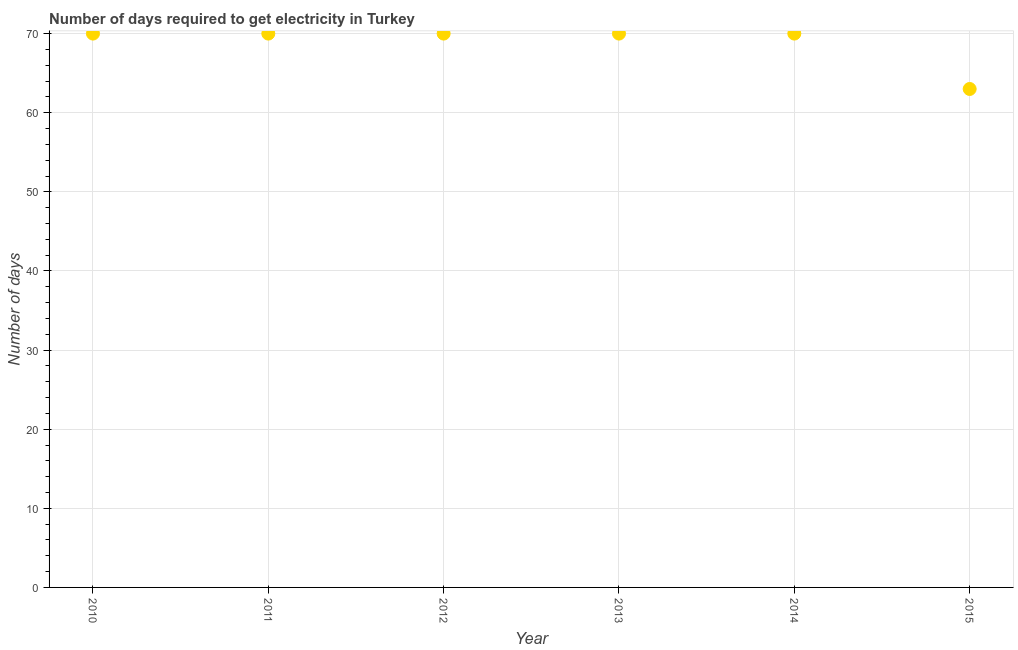What is the time to get electricity in 2011?
Give a very brief answer. 70. Across all years, what is the maximum time to get electricity?
Offer a very short reply. 70. Across all years, what is the minimum time to get electricity?
Provide a succinct answer. 63. In which year was the time to get electricity minimum?
Your answer should be very brief. 2015. What is the sum of the time to get electricity?
Your response must be concise. 413. What is the difference between the time to get electricity in 2010 and 2013?
Give a very brief answer. 0. What is the average time to get electricity per year?
Keep it short and to the point. 68.83. What is the median time to get electricity?
Make the answer very short. 70. In how many years, is the time to get electricity greater than 46 ?
Keep it short and to the point. 6. Is the sum of the time to get electricity in 2010 and 2012 greater than the maximum time to get electricity across all years?
Provide a succinct answer. Yes. What is the difference between the highest and the lowest time to get electricity?
Provide a succinct answer. 7. How many dotlines are there?
Offer a very short reply. 1. How many years are there in the graph?
Your response must be concise. 6. What is the difference between two consecutive major ticks on the Y-axis?
Offer a terse response. 10. Are the values on the major ticks of Y-axis written in scientific E-notation?
Provide a succinct answer. No. Does the graph contain any zero values?
Provide a short and direct response. No. What is the title of the graph?
Ensure brevity in your answer.  Number of days required to get electricity in Turkey. What is the label or title of the Y-axis?
Offer a very short reply. Number of days. What is the Number of days in 2013?
Offer a terse response. 70. What is the difference between the Number of days in 2010 and 2012?
Your response must be concise. 0. What is the difference between the Number of days in 2010 and 2015?
Provide a succinct answer. 7. What is the difference between the Number of days in 2011 and 2014?
Your answer should be very brief. 0. What is the difference between the Number of days in 2012 and 2014?
Keep it short and to the point. 0. What is the difference between the Number of days in 2013 and 2014?
Offer a very short reply. 0. What is the ratio of the Number of days in 2010 to that in 2012?
Provide a succinct answer. 1. What is the ratio of the Number of days in 2010 to that in 2013?
Offer a very short reply. 1. What is the ratio of the Number of days in 2010 to that in 2014?
Make the answer very short. 1. What is the ratio of the Number of days in 2010 to that in 2015?
Your answer should be very brief. 1.11. What is the ratio of the Number of days in 2011 to that in 2013?
Ensure brevity in your answer.  1. What is the ratio of the Number of days in 2011 to that in 2015?
Make the answer very short. 1.11. What is the ratio of the Number of days in 2012 to that in 2013?
Your response must be concise. 1. What is the ratio of the Number of days in 2012 to that in 2015?
Your answer should be compact. 1.11. What is the ratio of the Number of days in 2013 to that in 2015?
Give a very brief answer. 1.11. What is the ratio of the Number of days in 2014 to that in 2015?
Offer a terse response. 1.11. 